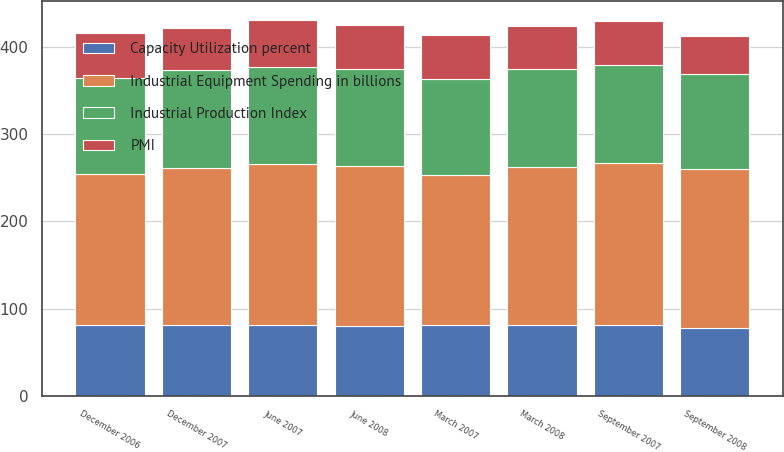<chart> <loc_0><loc_0><loc_500><loc_500><stacked_bar_chart><ecel><fcel>September 2008<fcel>June 2008<fcel>March 2008<fcel>December 2007<fcel>September 2007<fcel>June 2007<fcel>March 2007<fcel>December 2006<nl><fcel>Industrial Equipment Spending in billions<fcel>181.4<fcel>183.2<fcel>182<fcel>179.9<fcel>185.2<fcel>185.1<fcel>172.1<fcel>173.4<nl><fcel>Capacity Utilization percent<fcel>78.2<fcel>79.7<fcel>80.7<fcel>81<fcel>81.3<fcel>81<fcel>80.7<fcel>80.7<nl><fcel>PMI<fcel>43.5<fcel>50.2<fcel>48.6<fcel>48.4<fcel>50.5<fcel>53.4<fcel>50.7<fcel>51.5<nl><fcel>Industrial Production Index<fcel>109.7<fcel>111.4<fcel>112.3<fcel>112.2<fcel>112.1<fcel>111.1<fcel>110.2<fcel>109.8<nl></chart> 